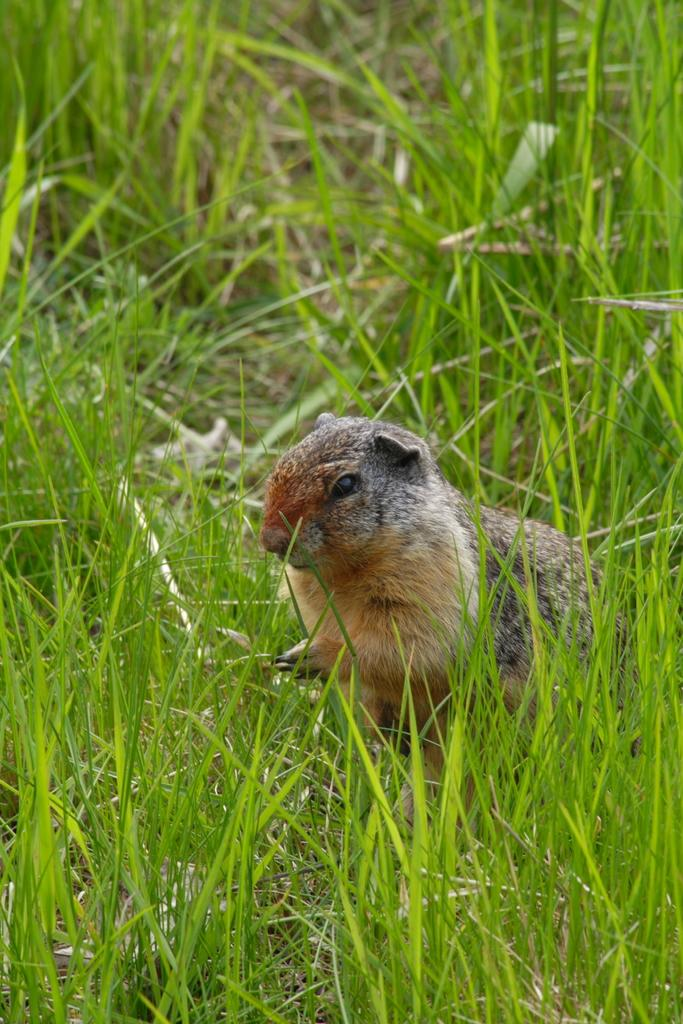What type of creature is in the image? There is an animal in the image. Can you describe the color of the animal? The animal is brown, grey, and black in color. What is the animal's position in the image? The animal is standing on the ground. What type of vegetation can be seen in the image? There is green grass visible in the image. What type of fruit is the animal holding in its mouth in the image? There is no fruit present in the image, and the animal is not holding anything in its mouth. 